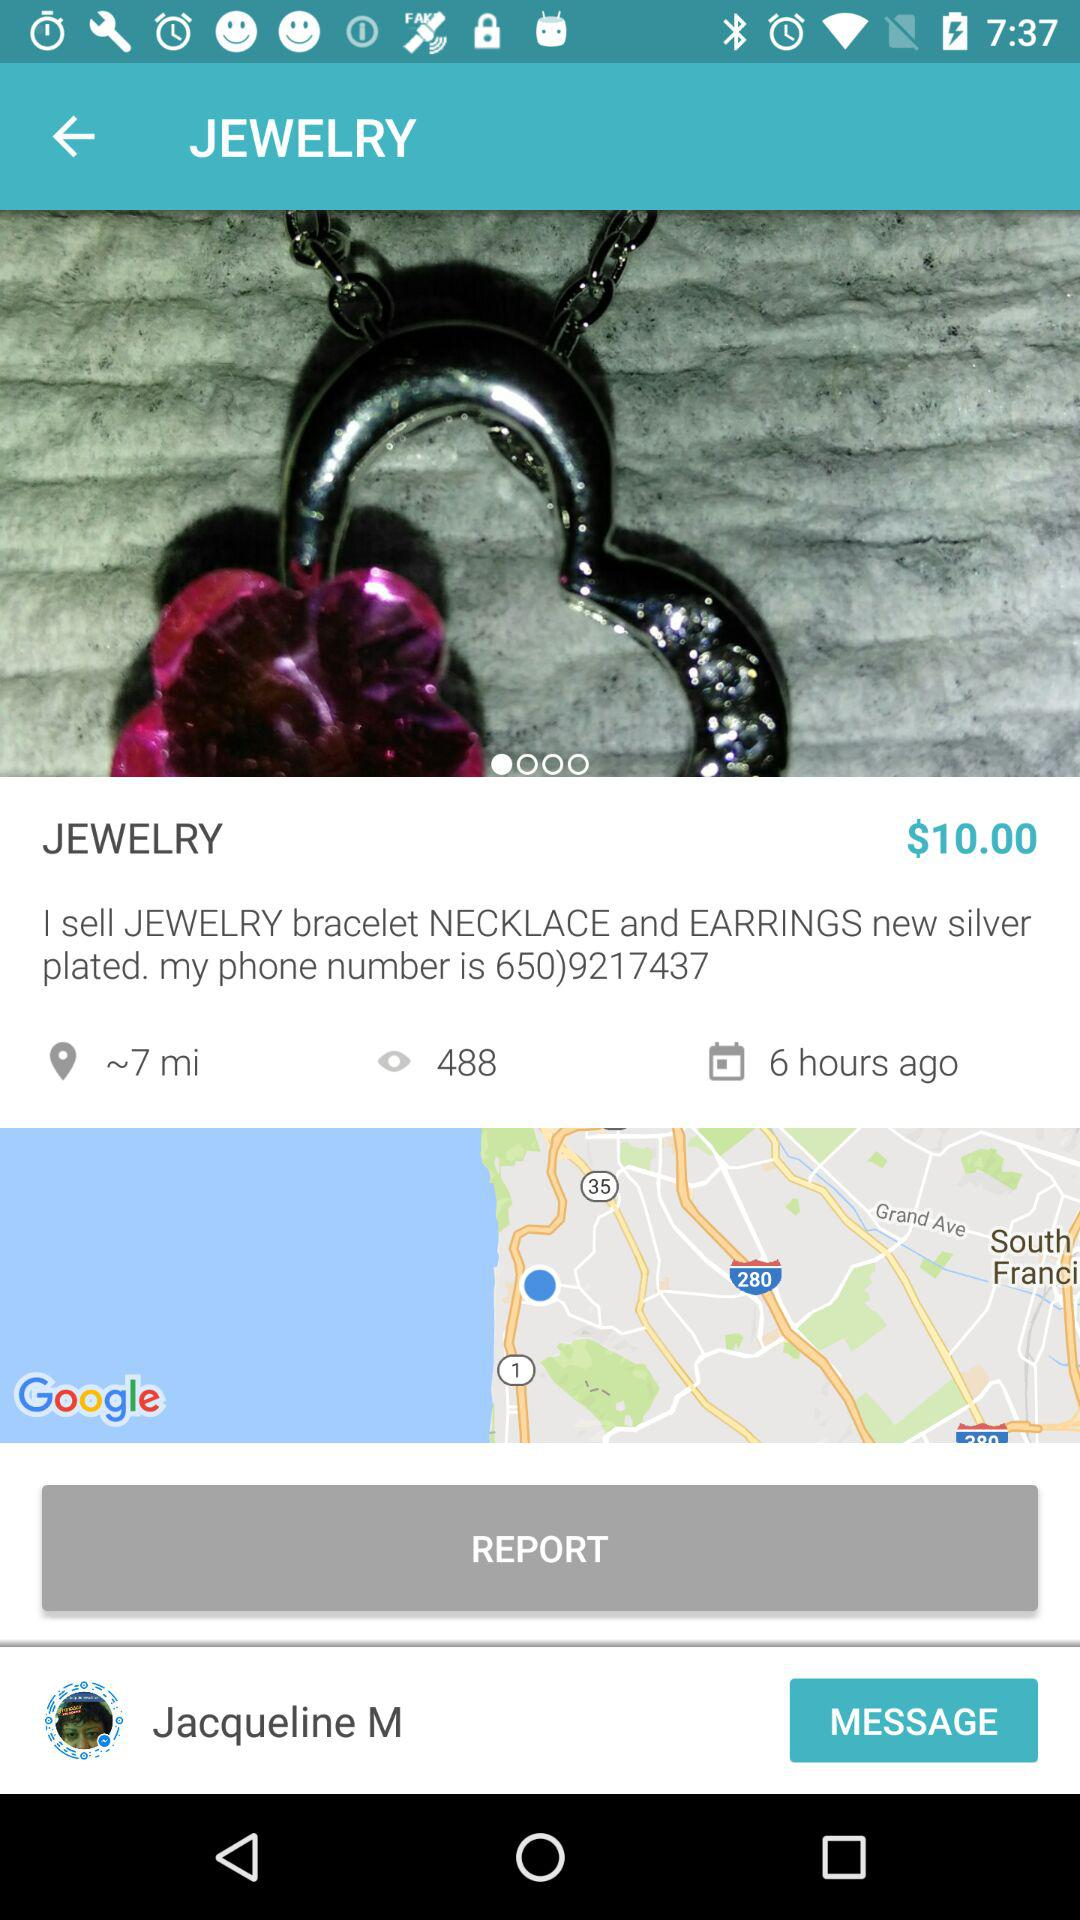What is the name of the user? The name of the user is Jacqueline M. 